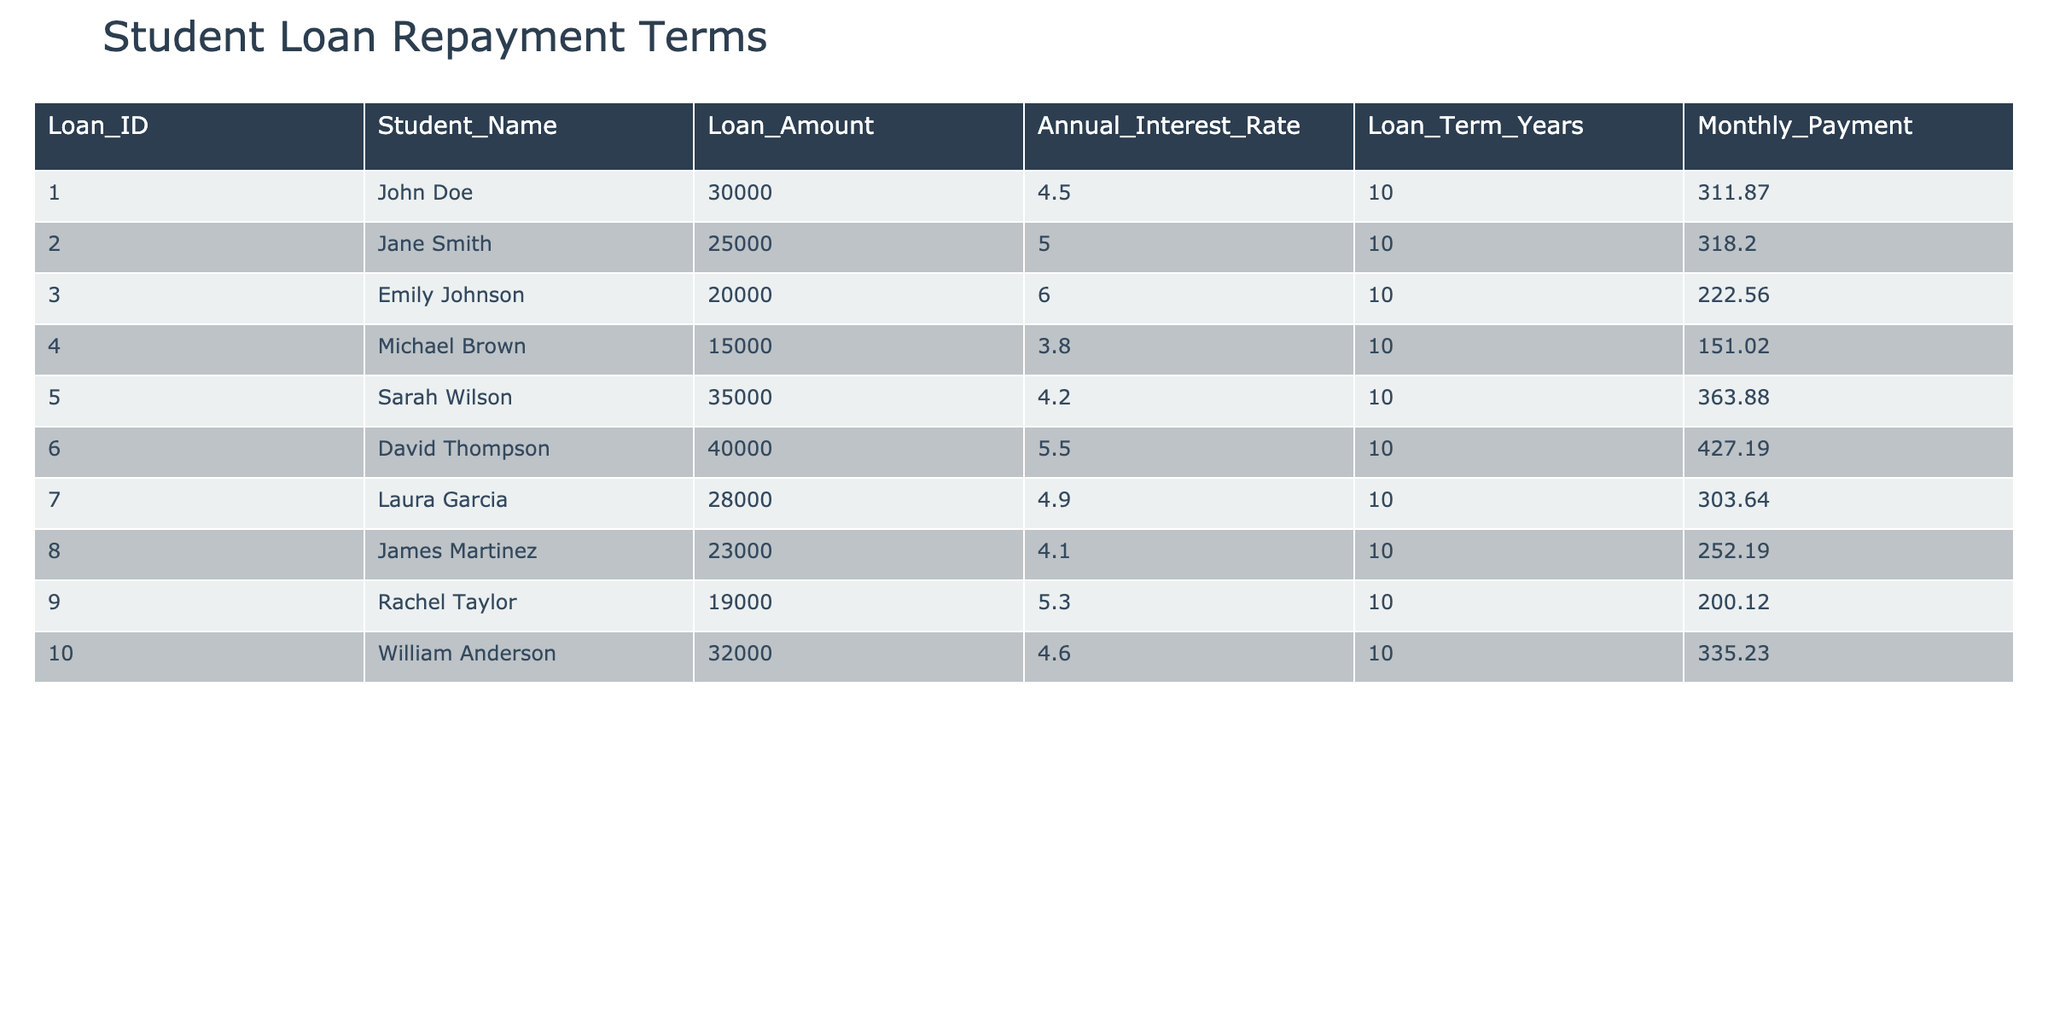What is the loan amount for Sarah Wilson? The table shows the row for Sarah Wilson, where the "Loan_Amount" column indicates her loan amount is 35000.
Answer: 35000 What is the monthly payment for Jane Smith? In the row corresponding to Jane Smith, the "Monthly_Payment" column lists her payment amount as 318.20.
Answer: 318.20 Which student has the highest monthly payment? By examining the "Monthly_Payment" column across all students, we find that Sarah Wilson has the highest payment at 363.88.
Answer: Sarah Wilson What is the total loan amount for all students in the table? Summing all the "Loan_Amount" values: 30000 + 25000 + 20000 + 15000 + 35000 + 40000 + 28000 + 23000 + 19000 + 32000 = 225000.
Answer: 225000 Is the annual interest rate for Emily Johnson higher than for Michael Brown? Emily Johnson has an interest rate of 6.0, while Michael Brown's rate is 3.8. Since 6.0 is greater than 3.8, the statement is true.
Answer: Yes What is the average monthly payment for all students? Calculate the average payment by summing all monthly payments (311.87 + 318.20 + 222.56 + 151.02 + 363.88 + 427.19 + 303.64 + 252.19 + 200.12 + 335.23 = 2389.00) and dividing by the number of students (10). 2389.00 / 10 = 238.90.
Answer: 238.90 Which student has the lowest interest rate? Comparing the "Annual_Interest_Rate" column, we see Michael Brown has the lowest rate at 3.8.
Answer: Michael Brown What is the difference between the highest and lowest loan amounts? The highest loan amount is 40000 (David Thompson) and the lowest is 15000 (Michael Brown). The difference is 40000 - 15000 = 25000.
Answer: 25000 Are there any students with a loan amount of less than 20000? By scanning through the "Loan_Amount" column, we see that the lowest amount is 15000, meaning there are students with loans under 20000.
Answer: Yes Which student has the lowest monthly payment? Looking through the "Monthly_Payment" column, we see Michael Brown has the lowest payment at 151.02.
Answer: Michael Brown 